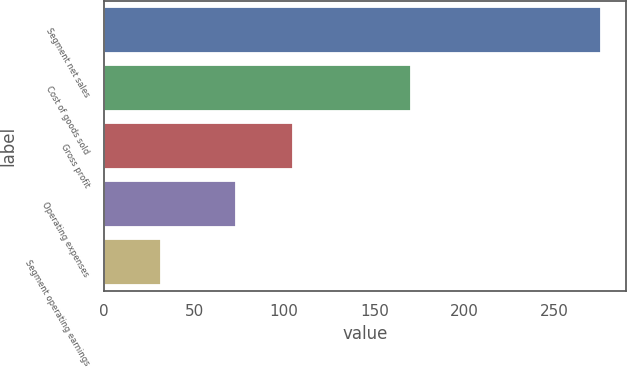Convert chart to OTSL. <chart><loc_0><loc_0><loc_500><loc_500><bar_chart><fcel>Segment net sales<fcel>Cost of goods sold<fcel>Gross profit<fcel>Operating expenses<fcel>Segment operating earnings<nl><fcel>275.6<fcel>170.6<fcel>105<fcel>73.1<fcel>31.9<nl></chart> 